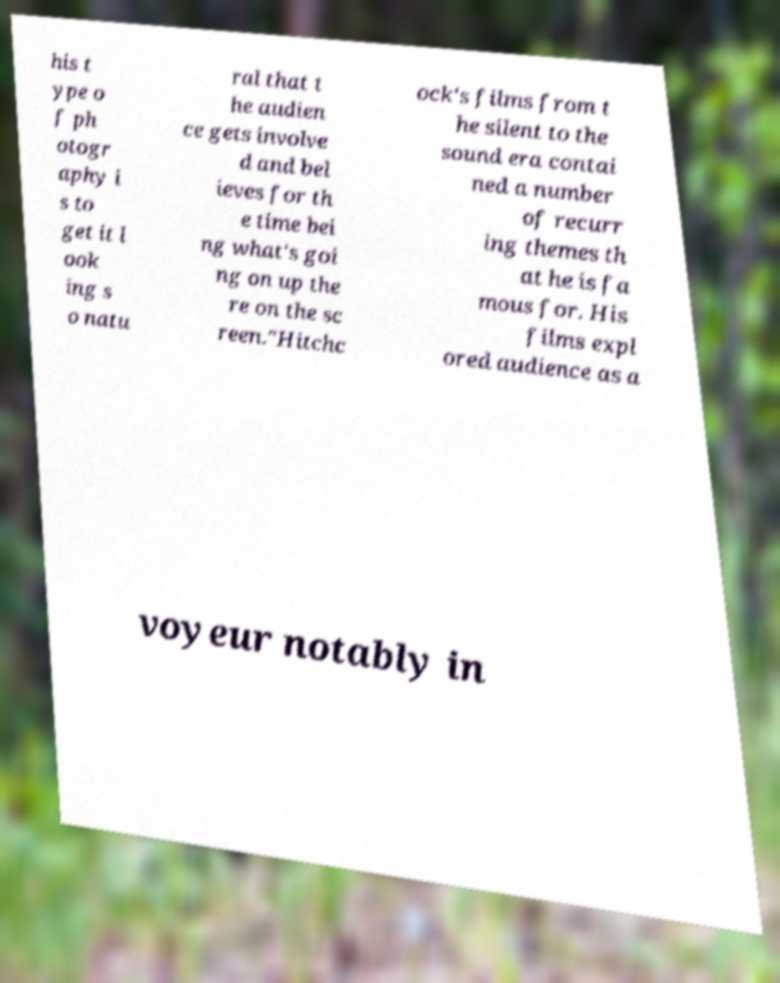Could you extract and type out the text from this image? his t ype o f ph otogr aphy i s to get it l ook ing s o natu ral that t he audien ce gets involve d and bel ieves for th e time bei ng what's goi ng on up the re on the sc reen."Hitchc ock's films from t he silent to the sound era contai ned a number of recurr ing themes th at he is fa mous for. His films expl ored audience as a voyeur notably in 